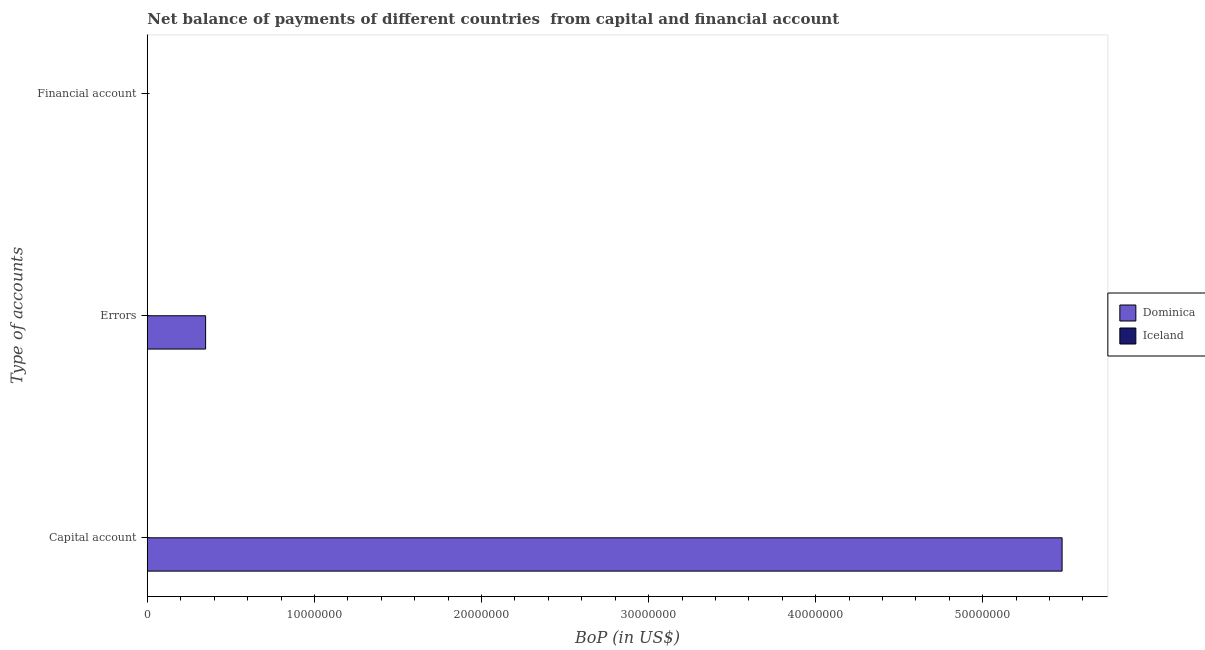Are the number of bars per tick equal to the number of legend labels?
Make the answer very short. No. Are the number of bars on each tick of the Y-axis equal?
Your answer should be compact. No. How many bars are there on the 2nd tick from the top?
Offer a terse response. 1. What is the label of the 3rd group of bars from the top?
Provide a short and direct response. Capital account. What is the amount of net capital account in Iceland?
Offer a terse response. 0. Across all countries, what is the maximum amount of net capital account?
Your response must be concise. 5.47e+07. Across all countries, what is the minimum amount of errors?
Offer a very short reply. 0. In which country was the amount of errors maximum?
Give a very brief answer. Dominica. What is the difference between the amount of errors in Iceland and the amount of financial account in Dominica?
Make the answer very short. 0. What is the average amount of errors per country?
Offer a terse response. 1.74e+06. What is the difference between the amount of net capital account and amount of errors in Dominica?
Your response must be concise. 5.13e+07. What is the difference between the highest and the lowest amount of net capital account?
Your answer should be very brief. 5.47e+07. In how many countries, is the amount of errors greater than the average amount of errors taken over all countries?
Your answer should be very brief. 1. How many bars are there?
Ensure brevity in your answer.  2. Are the values on the major ticks of X-axis written in scientific E-notation?
Your response must be concise. No. Does the graph contain any zero values?
Offer a very short reply. Yes. Does the graph contain grids?
Offer a terse response. No. How are the legend labels stacked?
Give a very brief answer. Vertical. What is the title of the graph?
Provide a succinct answer. Net balance of payments of different countries  from capital and financial account. What is the label or title of the X-axis?
Your answer should be compact. BoP (in US$). What is the label or title of the Y-axis?
Your answer should be compact. Type of accounts. What is the BoP (in US$) of Dominica in Capital account?
Offer a terse response. 5.47e+07. What is the BoP (in US$) of Dominica in Errors?
Provide a short and direct response. 3.49e+06. What is the BoP (in US$) in Iceland in Errors?
Keep it short and to the point. 0. What is the BoP (in US$) in Dominica in Financial account?
Keep it short and to the point. 0. What is the BoP (in US$) in Iceland in Financial account?
Provide a short and direct response. 0. Across all Type of accounts, what is the maximum BoP (in US$) in Dominica?
Provide a succinct answer. 5.47e+07. Across all Type of accounts, what is the minimum BoP (in US$) in Dominica?
Provide a short and direct response. 0. What is the total BoP (in US$) of Dominica in the graph?
Your response must be concise. 5.82e+07. What is the difference between the BoP (in US$) of Dominica in Capital account and that in Errors?
Keep it short and to the point. 5.13e+07. What is the average BoP (in US$) in Dominica per Type of accounts?
Keep it short and to the point. 1.94e+07. What is the average BoP (in US$) in Iceland per Type of accounts?
Ensure brevity in your answer.  0. What is the ratio of the BoP (in US$) in Dominica in Capital account to that in Errors?
Ensure brevity in your answer.  15.7. What is the difference between the highest and the lowest BoP (in US$) of Dominica?
Your answer should be compact. 5.47e+07. 